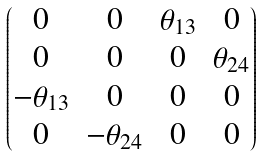<formula> <loc_0><loc_0><loc_500><loc_500>\begin{pmatrix} 0 & 0 & \theta _ { 1 3 } & 0 \\ 0 & 0 & 0 & \theta _ { 2 4 } \\ - \theta _ { 1 3 } & 0 & 0 & 0 \\ 0 & - \theta _ { 2 4 } & 0 & 0 \end{pmatrix}</formula> 